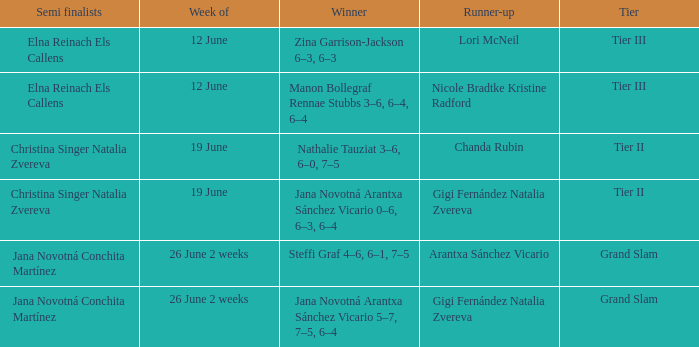In which week is the winner listed as Jana Novotná Arantxa Sánchez Vicario 5–7, 7–5, 6–4? 26 June 2 weeks. 